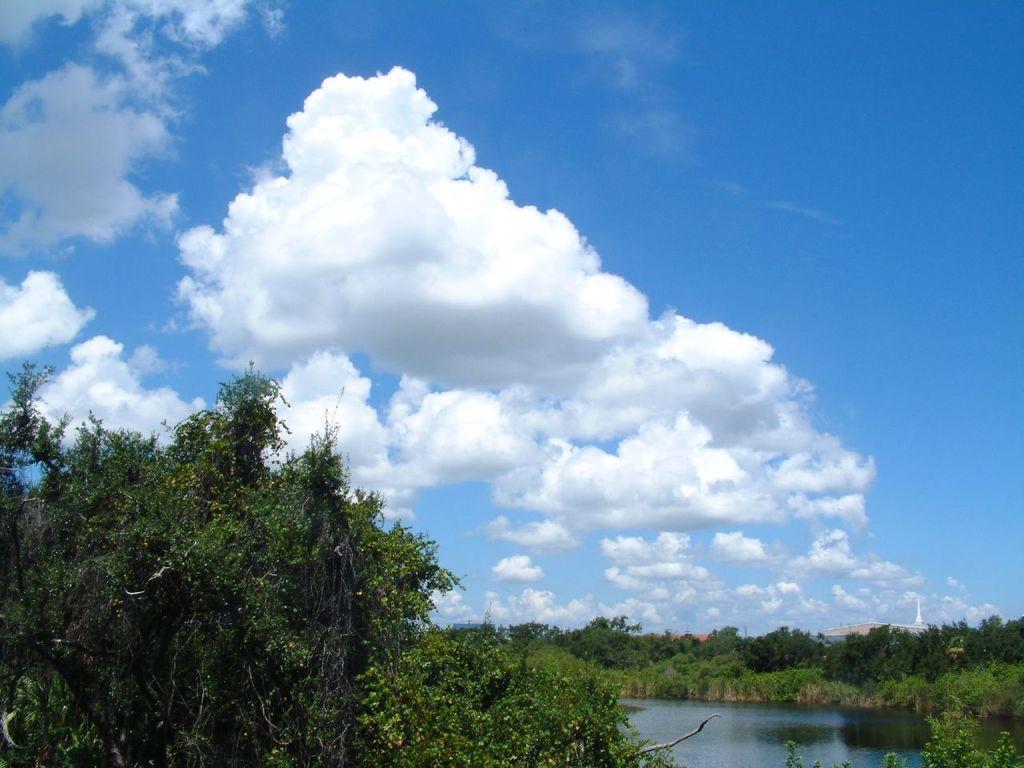How would you summarize this image in a sentence or two? In this image there is a lake in the middle and there are trees on either side of the lake. At the top there is the sky with the clouds. 